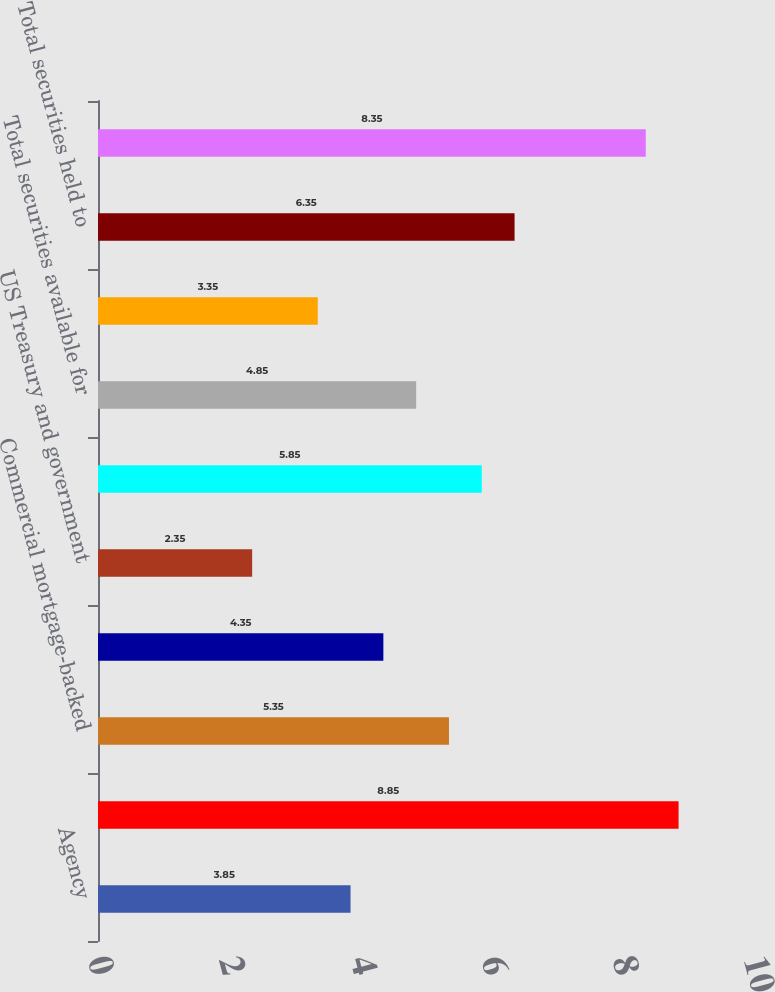Convert chart. <chart><loc_0><loc_0><loc_500><loc_500><bar_chart><fcel>Agency<fcel>Non-agency<fcel>Commercial mortgage-backed<fcel>Asset-backed<fcel>US Treasury and government<fcel>Other<fcel>Total securities available for<fcel>Asset-backed US Treasury and<fcel>Total securities held to<fcel>Residential real estate<nl><fcel>3.85<fcel>8.85<fcel>5.35<fcel>4.35<fcel>2.35<fcel>5.85<fcel>4.85<fcel>3.35<fcel>6.35<fcel>8.35<nl></chart> 